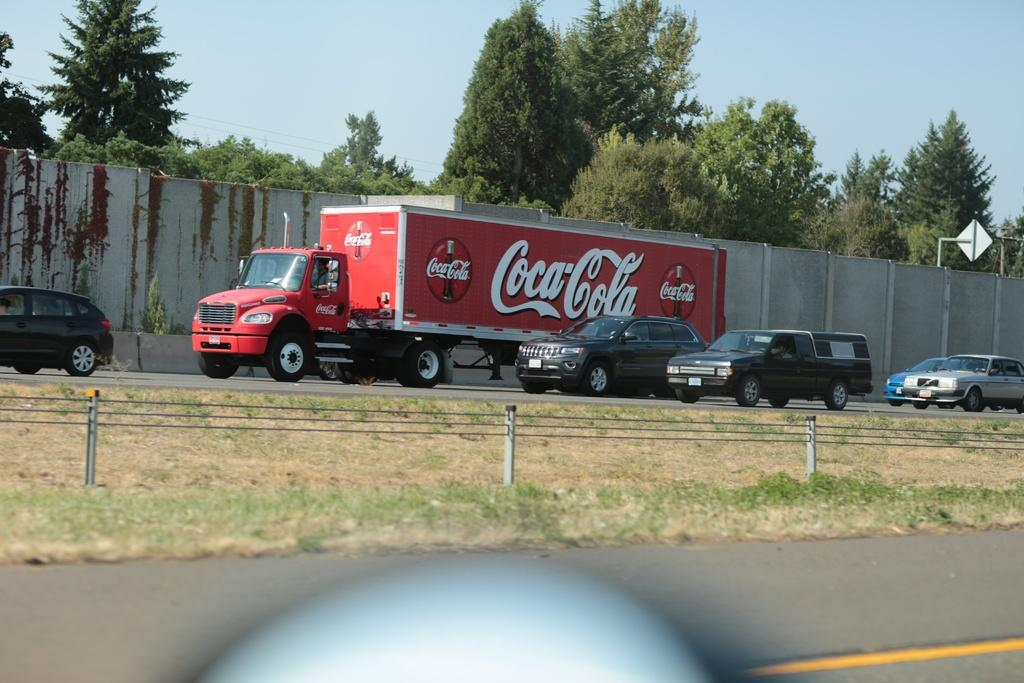What type of landscape is depicted in the image? There is a grassland in the image. What can be seen in the background of the image? Vehicles are moving on a road, there is a wall, trees, and the sky visible in the background. What type of attraction can be seen in the image? There is no specific attraction mentioned or depicted in the image. The image shows a grassland with vehicles moving on a road in the background, a wall, trees, and the sky. 